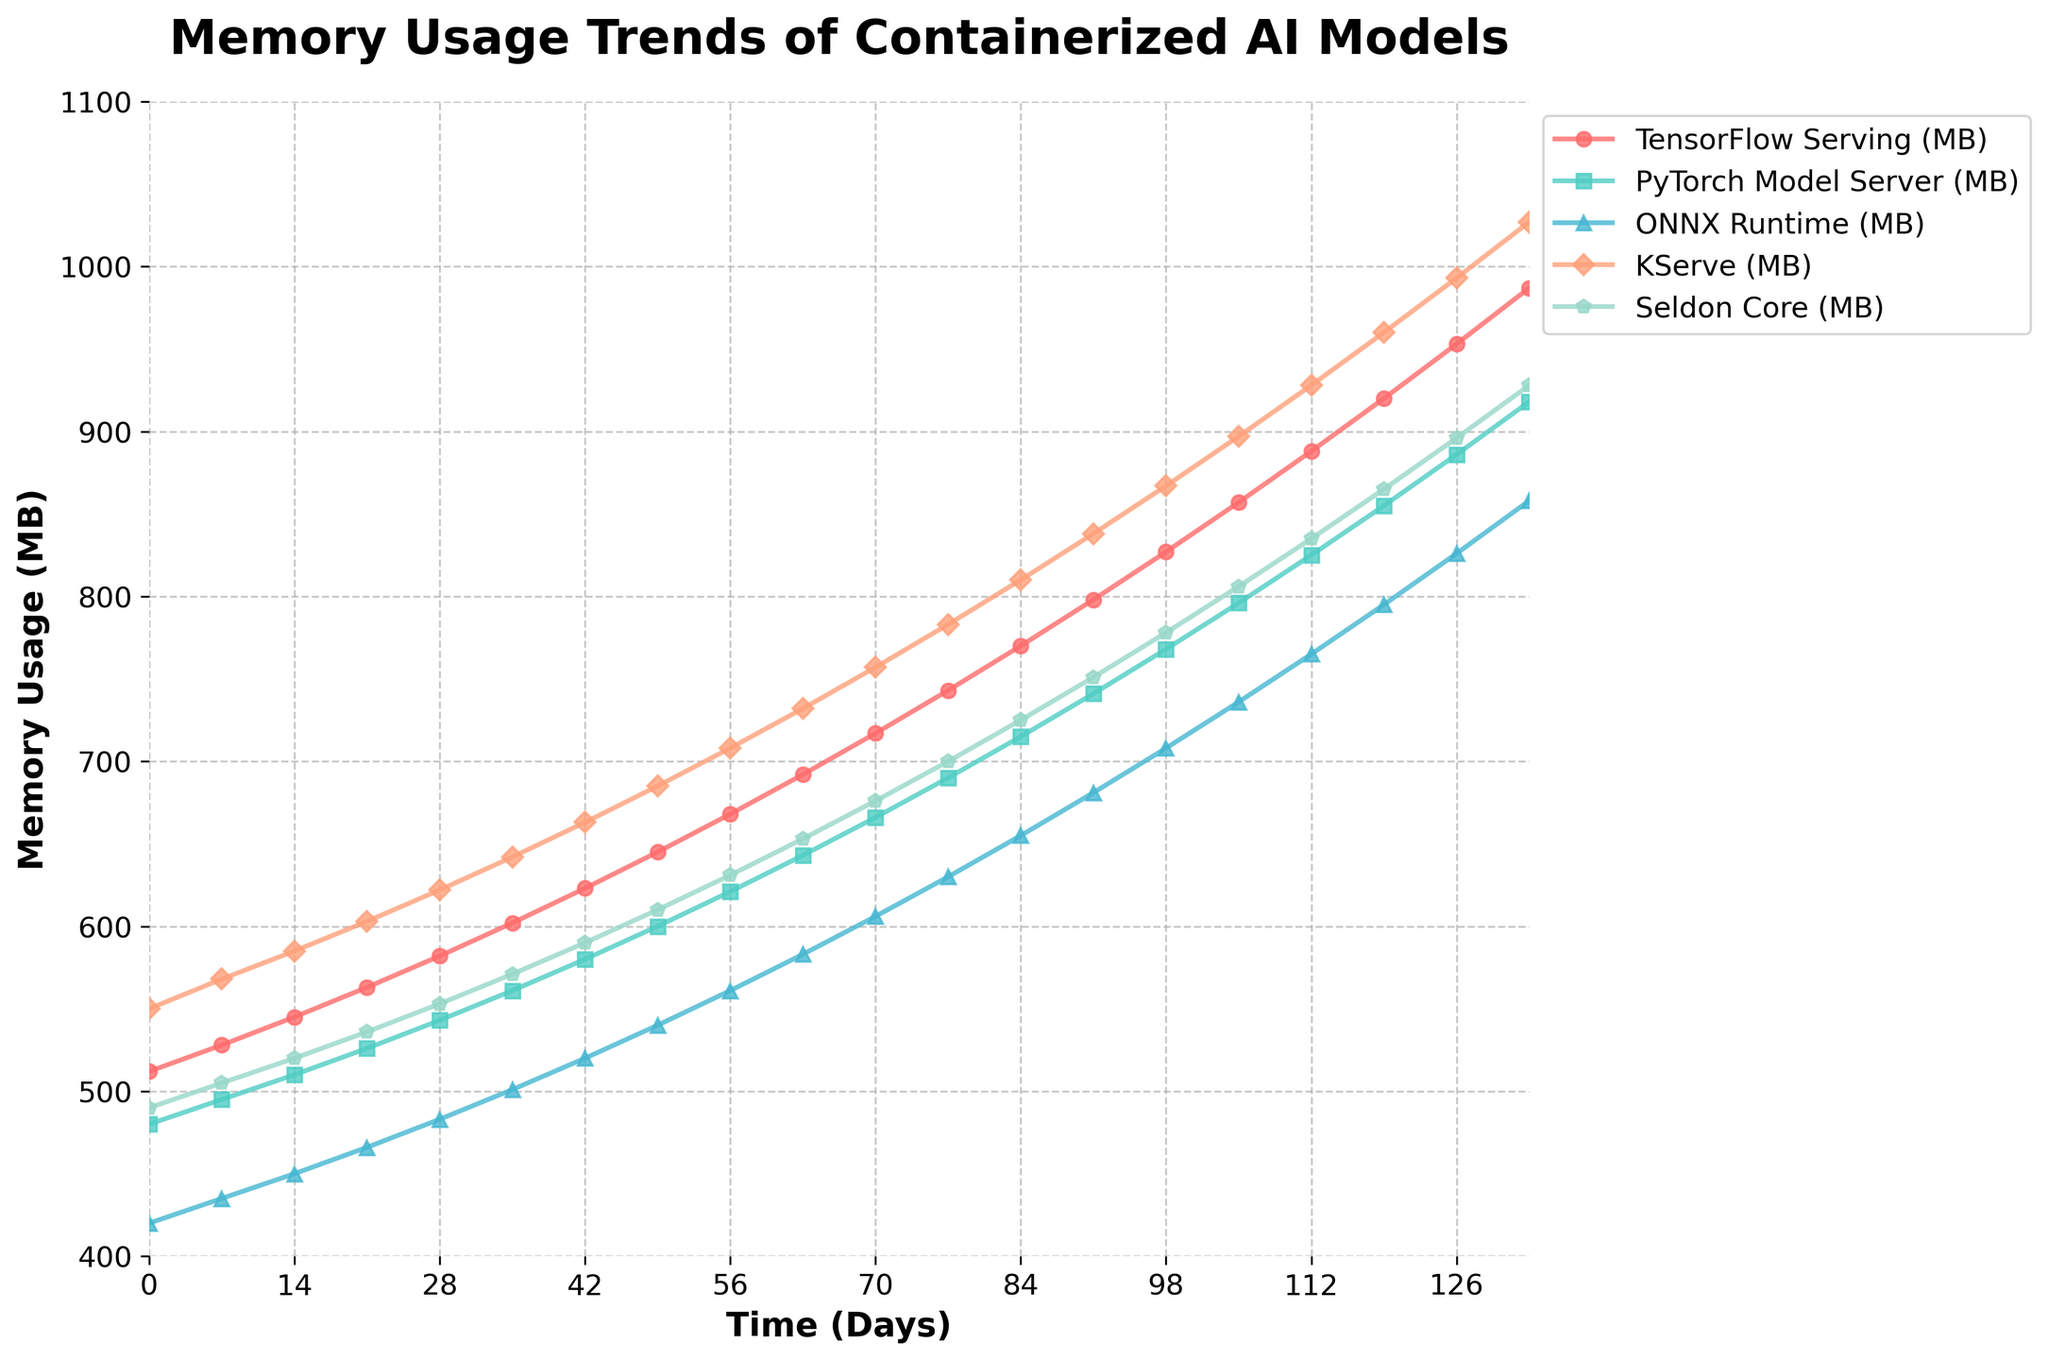What are the memory usage values for all the AI models on day 0? On day 0, look at the starting points of all the lines. TensorFlow Serving is at 512 MB, PyTorch Model Server at 480 MB, ONNX Runtime at 420 MB, KServe at 550 MB, and Seldon Core at 490 MB.
Answer: TensorFlow Serving: 512 MB, PyTorch Model Server: 480 MB, ONNX Runtime: 420 MB, KServe: 550 MB, Seldon Core: 490 MB Which AI model shows the highest memory usage at the end of the observation period? At day 133, check the endpoint values of all the lines. KServe reaches the highest value compared to all other models.
Answer: KServe By how much does TensorFlow Serving's memory usage increase from day 0 to day 133? Subtract TensorFlow Serving's memory usage on day 0 (512 MB) from its usage on day 133 (987 MB): 987 - 512 = 475 MB.
Answer: 475 MB Which AI model has the lowest average memory usage over the observation period? Calculate average values for each model over the given days. Visual comparison shows that ONNX Runtime stays lower overall compared to others.
Answer: ONNX Runtime How do the trends of memory usage for KServe and Seldon Core compare over the period? Both models start with a similar pattern but KServe's memory usage consistently increases at a steeper rate than Seldon Core, ending with a higher value at day 133.
Answer: KServe increases faster and ends higher What is the median memory usage value for PyTorch Model Server? List all the values for PyTorch and find the middle value in the sorted series. Given there are 20 data points (even), find the average of the 10th and 11th values: (643 + 666)/2 = 654.5 MB.
Answer: 654.5 MB Which model has the steepest increase in memory usage between day 49 and day 63? Calculate the difference in memory usage between day 49 and day 63 for each model and compare them. KServe has the highest increment (732 - 685 = 47 MB).
Answer: KServe Between days 0 and 105, which model grows the slowest in terms of memory usage? Compare the increments of all models over this period: (day 105 value - day 0 value). ONNX Runtime has the smallest increase (736 - 420 = 316 MB).
Answer: ONNX Runtime 